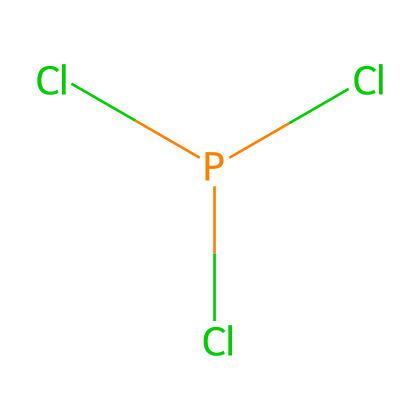How many chlorine atoms are in phosphorus trichloride? The SMILES representation indicates there are three chlorine (Cl) atoms connected to the phosphorus (P) atom, which is evident from the notation "Cl[P](Cl)Cl".
Answer: three What is the central atom in this structure? The structure shows a phosphorus atom (P) as the central atom since it is bonded to the three chlorine atoms and is represented by the "P" in the SMILES notation.
Answer: phosphorus What type of bonding is present in phosphorus trichloride? The bonds between the phosphorus and chlorine atoms are covalent bonds, as they share electrons to form stable pairs, which is characteristic of Phosphorus compounds.
Answer: covalent What is the molecular geometry of phosphorus trichloride? Given that phosphorus trichloride has a trigonal pyramidal geometry, this results from one lone pair on phosphorus, along with the three bonds to chlorine atoms creating the pyramidal shape.
Answer: trigonal pyramidal What is the hybridization of the central phosphorus atom? The bonding and lone pair arrangement in phosphorus trichloride lead to the hybridization of the phosphorus atom being sp³, as it accommodates one lone pair and forms three sigma bonds with chlorine.
Answer: sp3 Is phosphorus trichloride polar or nonpolar? The asymmetrical shape due to the lone pair results in a net dipole moment, making phosphorus trichloride a polar molecule.
Answer: polar 